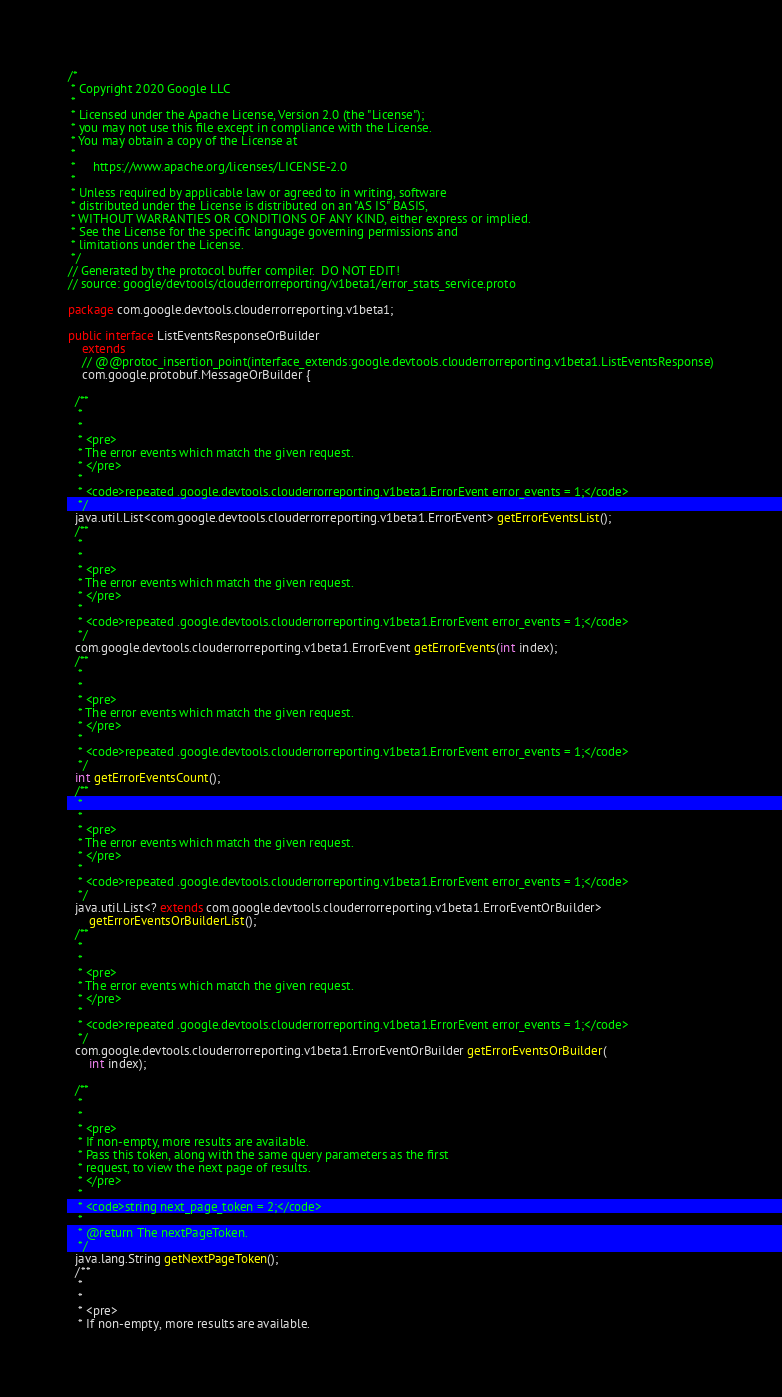Convert code to text. <code><loc_0><loc_0><loc_500><loc_500><_Java_>/*
 * Copyright 2020 Google LLC
 *
 * Licensed under the Apache License, Version 2.0 (the "License");
 * you may not use this file except in compliance with the License.
 * You may obtain a copy of the License at
 *
 *     https://www.apache.org/licenses/LICENSE-2.0
 *
 * Unless required by applicable law or agreed to in writing, software
 * distributed under the License is distributed on an "AS IS" BASIS,
 * WITHOUT WARRANTIES OR CONDITIONS OF ANY KIND, either express or implied.
 * See the License for the specific language governing permissions and
 * limitations under the License.
 */
// Generated by the protocol buffer compiler.  DO NOT EDIT!
// source: google/devtools/clouderrorreporting/v1beta1/error_stats_service.proto

package com.google.devtools.clouderrorreporting.v1beta1;

public interface ListEventsResponseOrBuilder
    extends
    // @@protoc_insertion_point(interface_extends:google.devtools.clouderrorreporting.v1beta1.ListEventsResponse)
    com.google.protobuf.MessageOrBuilder {

  /**
   *
   *
   * <pre>
   * The error events which match the given request.
   * </pre>
   *
   * <code>repeated .google.devtools.clouderrorreporting.v1beta1.ErrorEvent error_events = 1;</code>
   */
  java.util.List<com.google.devtools.clouderrorreporting.v1beta1.ErrorEvent> getErrorEventsList();
  /**
   *
   *
   * <pre>
   * The error events which match the given request.
   * </pre>
   *
   * <code>repeated .google.devtools.clouderrorreporting.v1beta1.ErrorEvent error_events = 1;</code>
   */
  com.google.devtools.clouderrorreporting.v1beta1.ErrorEvent getErrorEvents(int index);
  /**
   *
   *
   * <pre>
   * The error events which match the given request.
   * </pre>
   *
   * <code>repeated .google.devtools.clouderrorreporting.v1beta1.ErrorEvent error_events = 1;</code>
   */
  int getErrorEventsCount();
  /**
   *
   *
   * <pre>
   * The error events which match the given request.
   * </pre>
   *
   * <code>repeated .google.devtools.clouderrorreporting.v1beta1.ErrorEvent error_events = 1;</code>
   */
  java.util.List<? extends com.google.devtools.clouderrorreporting.v1beta1.ErrorEventOrBuilder>
      getErrorEventsOrBuilderList();
  /**
   *
   *
   * <pre>
   * The error events which match the given request.
   * </pre>
   *
   * <code>repeated .google.devtools.clouderrorreporting.v1beta1.ErrorEvent error_events = 1;</code>
   */
  com.google.devtools.clouderrorreporting.v1beta1.ErrorEventOrBuilder getErrorEventsOrBuilder(
      int index);

  /**
   *
   *
   * <pre>
   * If non-empty, more results are available.
   * Pass this token, along with the same query parameters as the first
   * request, to view the next page of results.
   * </pre>
   *
   * <code>string next_page_token = 2;</code>
   *
   * @return The nextPageToken.
   */
  java.lang.String getNextPageToken();
  /**
   *
   *
   * <pre>
   * If non-empty, more results are available.</code> 